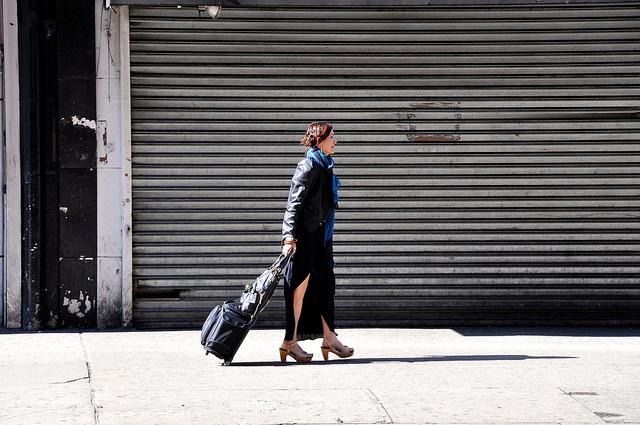What is the woman pulling?
Short answer required. Suitcase. What color is the suitcase?
Concise answer only. Black. Is the woman wearing high heels?
Keep it brief. Yes. Is this picture old?
Be succinct. No. Is this woman walking in front of a fancy house?
Concise answer only. No. 